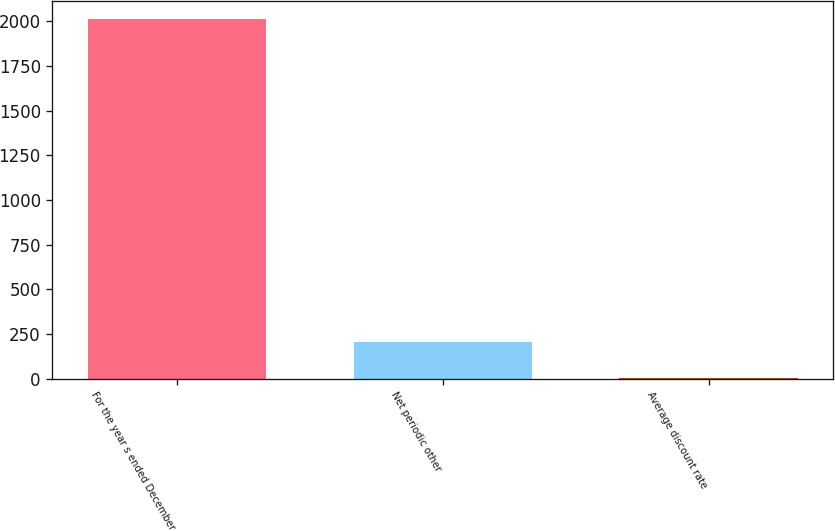Convert chart to OTSL. <chart><loc_0><loc_0><loc_500><loc_500><bar_chart><fcel>For the year s ended December<fcel>Net periodic other<fcel>Average discount rate<nl><fcel>2013<fcel>204.63<fcel>3.7<nl></chart> 